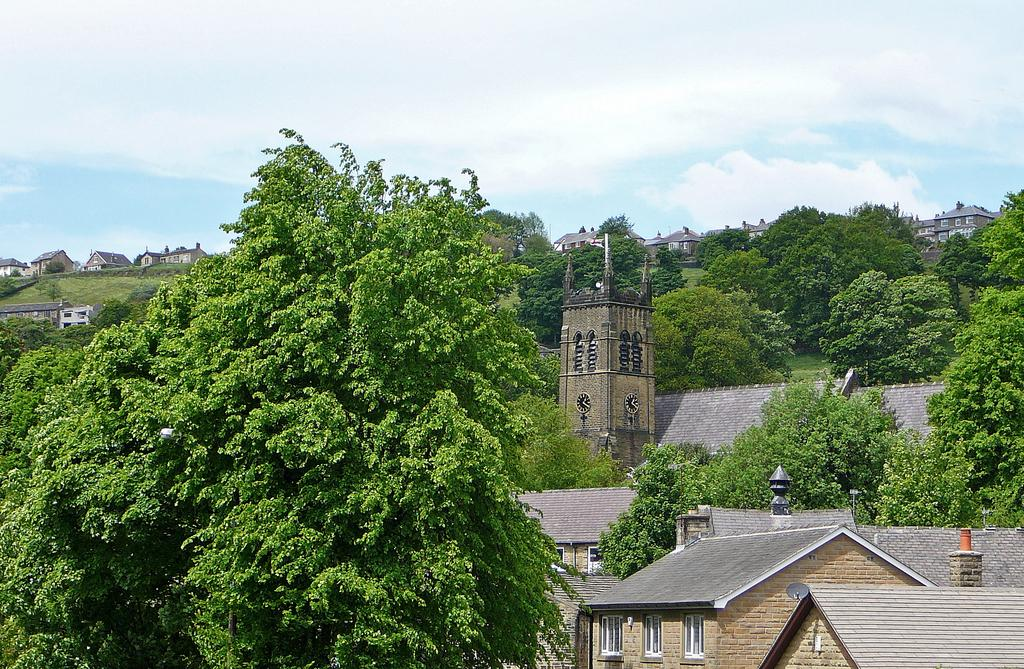What type of structures can be seen in the image? There are houses in the image. What other natural elements are present in the image? There are trees in the image. What type of mine can be seen in the image? There is no mine present in the image; it features houses and trees. How does the tongue interact with the houses in the image? There is no tongue present in the image, as it is a scene with houses and trees. 